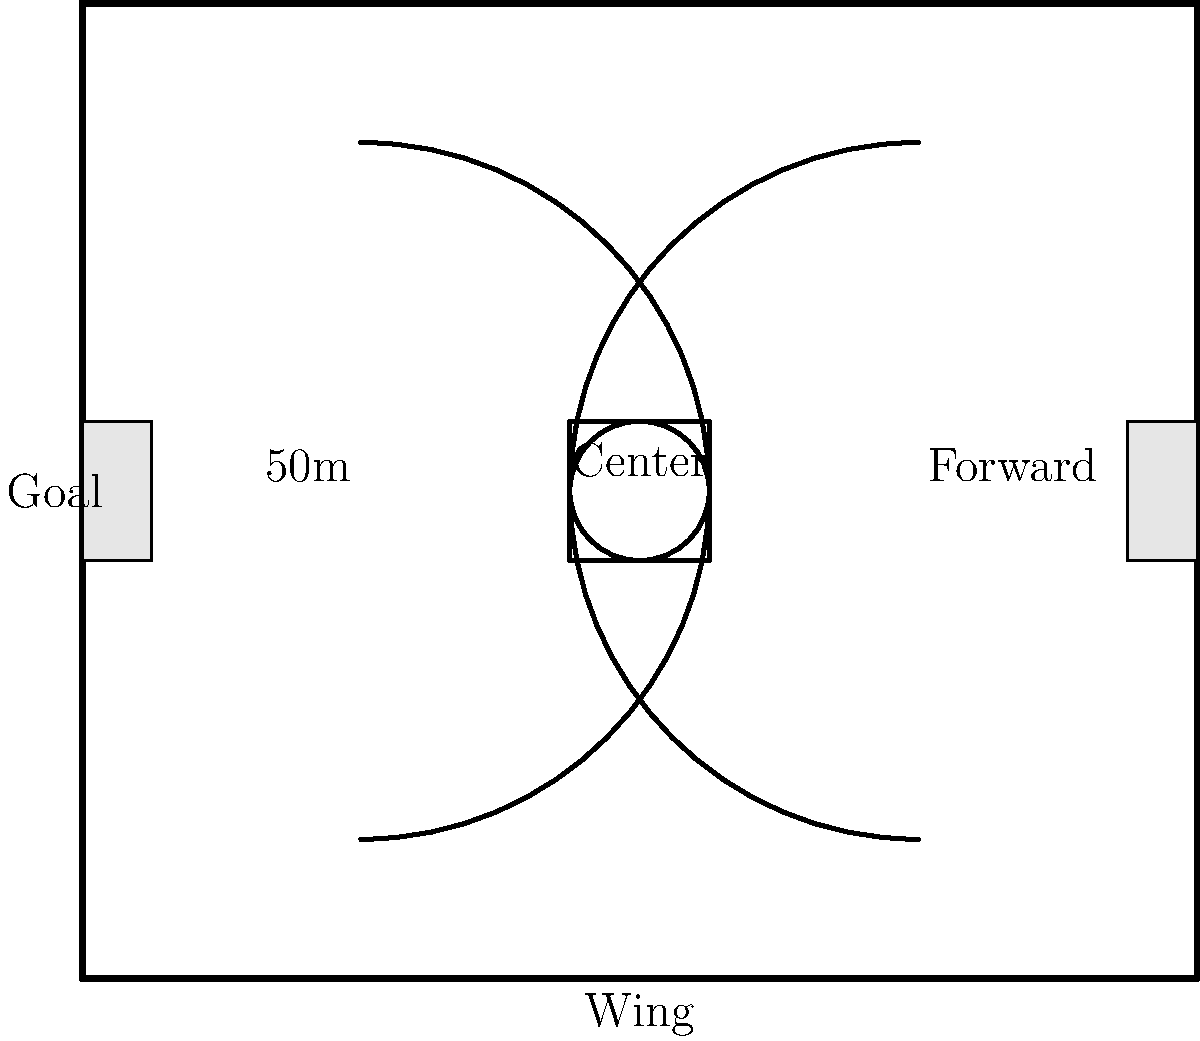In an Australian football field, which zone is typically associated with midfielders like Heath Scotland, and what shape does it form on the field? To answer this question, let's break down the key areas of an Australian football field:

1. The field is divided into several zones, each with specific roles.
2. The center of the field is marked by a circular area.
3. Around this central circle is a larger square, known as the center square.
4. Midfielders, like Heath Scotland, often play a crucial role in this central area.
5. The center square is where the ruck contests and ball-ups occur to restart play.
6. This area is critical for winning possession and distributing the ball to teammates.
7. The shape of this zone, as seen in the diagram, is a square.
8. It's positioned in the middle of the field, surrounding the center circle.

Given Heath Scotland's role as a midfielder, he would have frequently operated within and around this center square area during his playing career.
Answer: Center square 